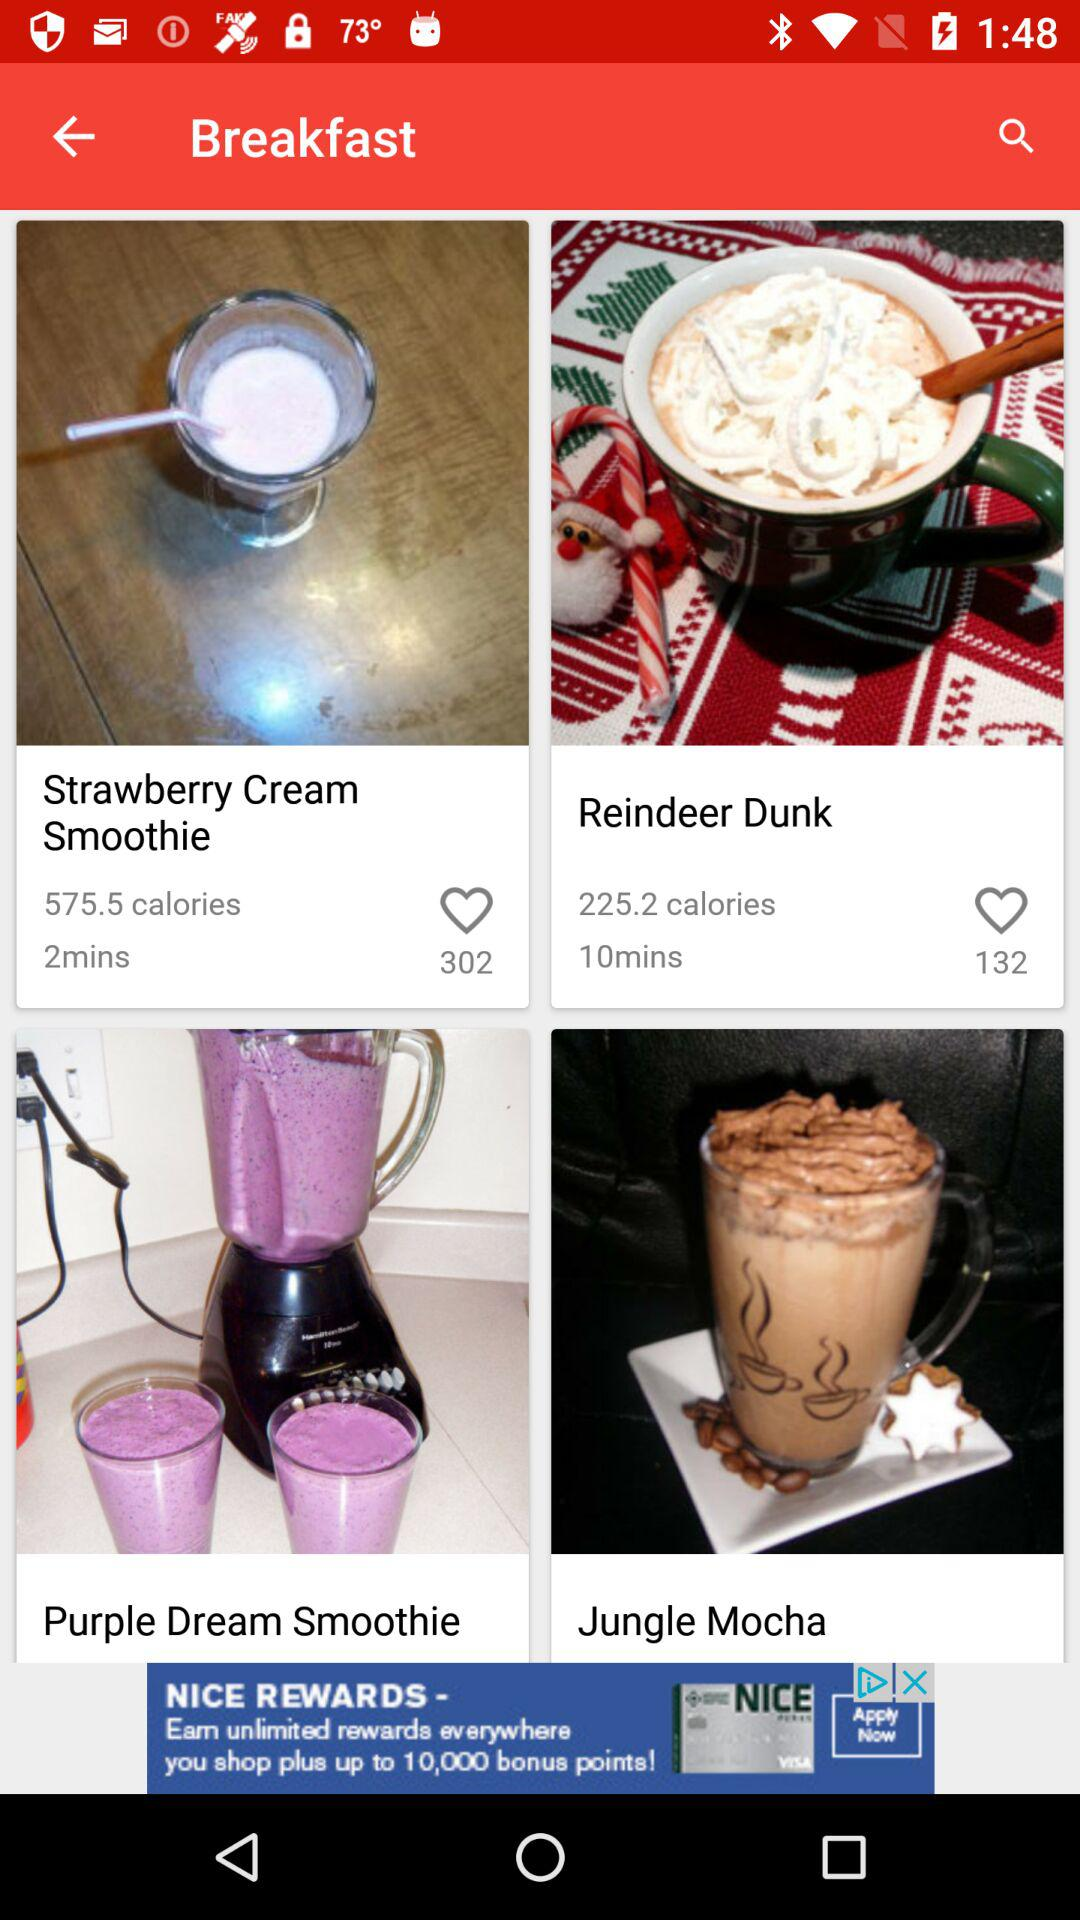How many calories in a "Jungle Mocha"?
When the provided information is insufficient, respond with <no answer>. <no answer> 